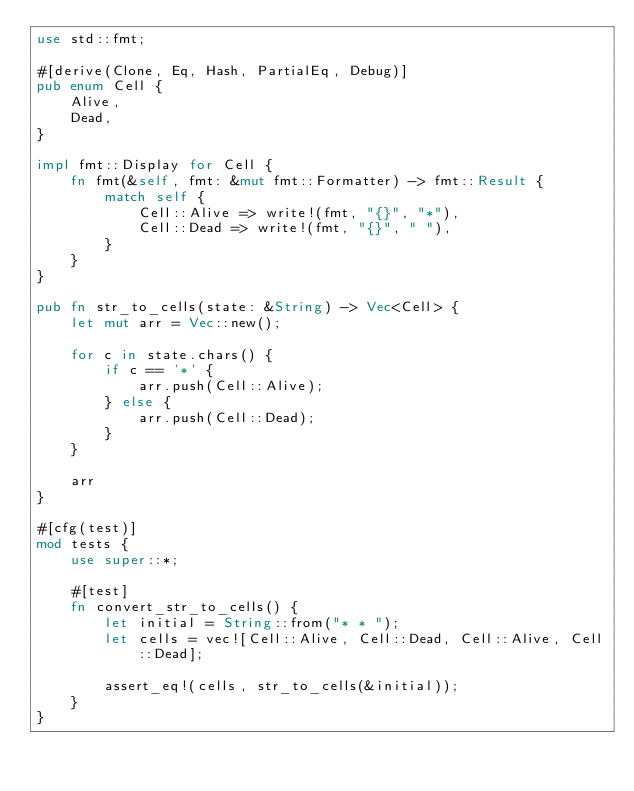Convert code to text. <code><loc_0><loc_0><loc_500><loc_500><_Rust_>use std::fmt;

#[derive(Clone, Eq, Hash, PartialEq, Debug)]
pub enum Cell {
    Alive,
    Dead,
}

impl fmt::Display for Cell {
    fn fmt(&self, fmt: &mut fmt::Formatter) -> fmt::Result {
        match self {
            Cell::Alive => write!(fmt, "{}", "*"),
            Cell::Dead => write!(fmt, "{}", " "),
        }
    }
}

pub fn str_to_cells(state: &String) -> Vec<Cell> {
    let mut arr = Vec::new();

    for c in state.chars() {
        if c == '*' {
            arr.push(Cell::Alive);
        } else {
            arr.push(Cell::Dead);
        }
    }

    arr
}

#[cfg(test)]
mod tests {
    use super::*;

    #[test]
    fn convert_str_to_cells() {
        let initial = String::from("* * ");
        let cells = vec![Cell::Alive, Cell::Dead, Cell::Alive, Cell::Dead];

        assert_eq!(cells, str_to_cells(&initial));
    }
}
</code> 